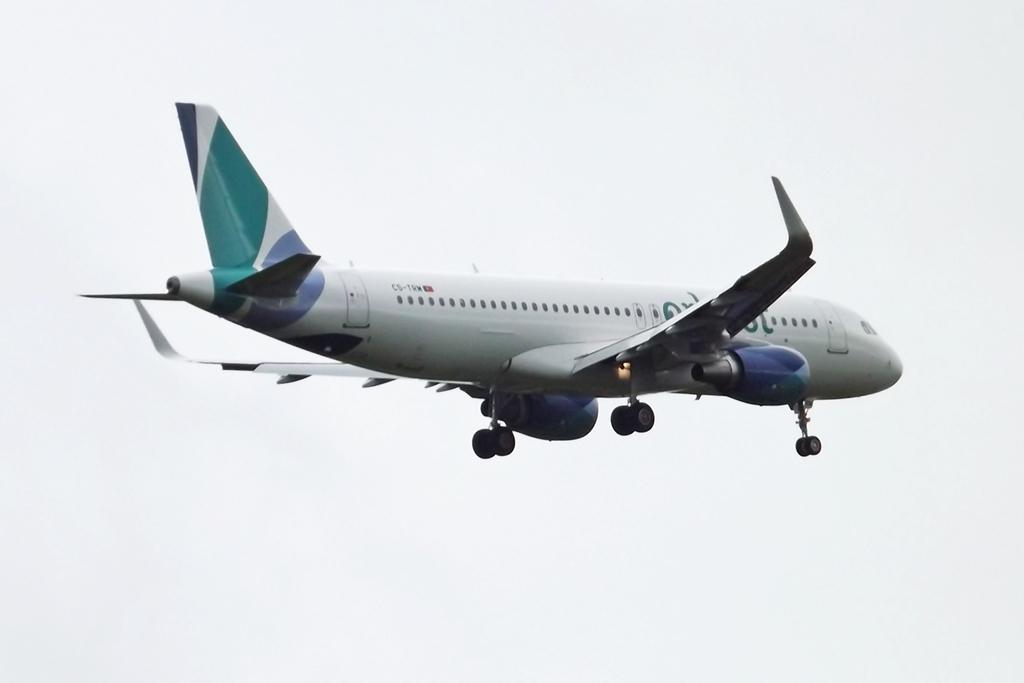What is the main subject of the image? The main subject of the image is an airplane. Can you describe the position of the airplane in the image? The airplane is in the air in the image. What can be seen in the background of the image? The sky is visible in the background of the image. What type of curtain can be seen hanging from the airplane in the image? There is no curtain present on the airplane in the image. What is the taste of the airplane in the image? Airplanes do not have a taste, as they are not edible. 